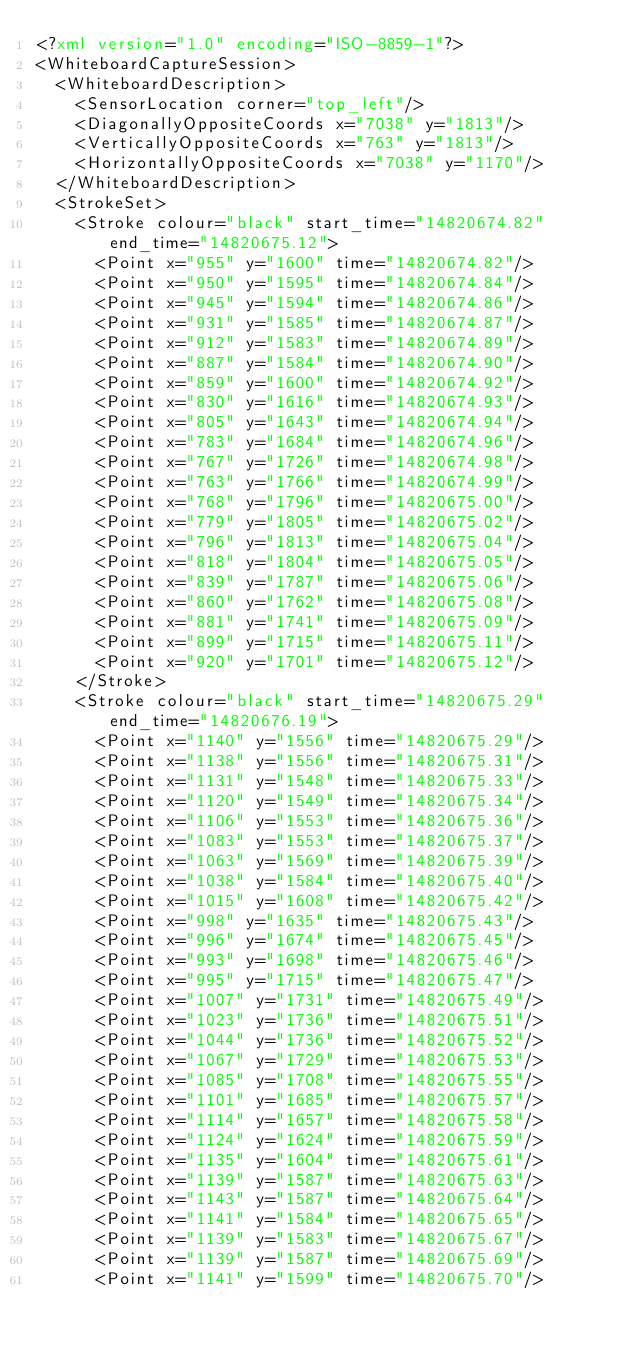Convert code to text. <code><loc_0><loc_0><loc_500><loc_500><_XML_><?xml version="1.0" encoding="ISO-8859-1"?>
<WhiteboardCaptureSession>
  <WhiteboardDescription>
    <SensorLocation corner="top_left"/>
    <DiagonallyOppositeCoords x="7038" y="1813"/>
    <VerticallyOppositeCoords x="763" y="1813"/>
    <HorizontallyOppositeCoords x="7038" y="1170"/>
  </WhiteboardDescription>
  <StrokeSet>
    <Stroke colour="black" start_time="14820674.82" end_time="14820675.12">
      <Point x="955" y="1600" time="14820674.82"/>
      <Point x="950" y="1595" time="14820674.84"/>
      <Point x="945" y="1594" time="14820674.86"/>
      <Point x="931" y="1585" time="14820674.87"/>
      <Point x="912" y="1583" time="14820674.89"/>
      <Point x="887" y="1584" time="14820674.90"/>
      <Point x="859" y="1600" time="14820674.92"/>
      <Point x="830" y="1616" time="14820674.93"/>
      <Point x="805" y="1643" time="14820674.94"/>
      <Point x="783" y="1684" time="14820674.96"/>
      <Point x="767" y="1726" time="14820674.98"/>
      <Point x="763" y="1766" time="14820674.99"/>
      <Point x="768" y="1796" time="14820675.00"/>
      <Point x="779" y="1805" time="14820675.02"/>
      <Point x="796" y="1813" time="14820675.04"/>
      <Point x="818" y="1804" time="14820675.05"/>
      <Point x="839" y="1787" time="14820675.06"/>
      <Point x="860" y="1762" time="14820675.08"/>
      <Point x="881" y="1741" time="14820675.09"/>
      <Point x="899" y="1715" time="14820675.11"/>
      <Point x="920" y="1701" time="14820675.12"/>
    </Stroke>
    <Stroke colour="black" start_time="14820675.29" end_time="14820676.19">
      <Point x="1140" y="1556" time="14820675.29"/>
      <Point x="1138" y="1556" time="14820675.31"/>
      <Point x="1131" y="1548" time="14820675.33"/>
      <Point x="1120" y="1549" time="14820675.34"/>
      <Point x="1106" y="1553" time="14820675.36"/>
      <Point x="1083" y="1553" time="14820675.37"/>
      <Point x="1063" y="1569" time="14820675.39"/>
      <Point x="1038" y="1584" time="14820675.40"/>
      <Point x="1015" y="1608" time="14820675.42"/>
      <Point x="998" y="1635" time="14820675.43"/>
      <Point x="996" y="1674" time="14820675.45"/>
      <Point x="993" y="1698" time="14820675.46"/>
      <Point x="995" y="1715" time="14820675.47"/>
      <Point x="1007" y="1731" time="14820675.49"/>
      <Point x="1023" y="1736" time="14820675.51"/>
      <Point x="1044" y="1736" time="14820675.52"/>
      <Point x="1067" y="1729" time="14820675.53"/>
      <Point x="1085" y="1708" time="14820675.55"/>
      <Point x="1101" y="1685" time="14820675.57"/>
      <Point x="1114" y="1657" time="14820675.58"/>
      <Point x="1124" y="1624" time="14820675.59"/>
      <Point x="1135" y="1604" time="14820675.61"/>
      <Point x="1139" y="1587" time="14820675.63"/>
      <Point x="1143" y="1587" time="14820675.64"/>
      <Point x="1141" y="1584" time="14820675.65"/>
      <Point x="1139" y="1583" time="14820675.67"/>
      <Point x="1139" y="1587" time="14820675.69"/>
      <Point x="1141" y="1599" time="14820675.70"/></code> 